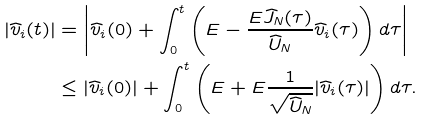<formula> <loc_0><loc_0><loc_500><loc_500>| \widehat { v } _ { i } ( t ) | & = \left | \widehat { v } _ { i } ( 0 ) + \int _ { 0 } ^ { t } \left ( E - \frac { E \widehat { J } _ { N } ( \tau ) } { \widehat { U } _ { N } } \widehat { v } _ { i } ( \tau ) \right ) d \tau \right | \\ & \leq | \widehat { v } _ { i } ( 0 ) | + \int _ { 0 } ^ { t } \left ( E + E \frac { 1 } { \sqrt { \widehat { U } _ { N } } } | \widehat { v } _ { i } ( \tau ) | \right ) d \tau .</formula> 